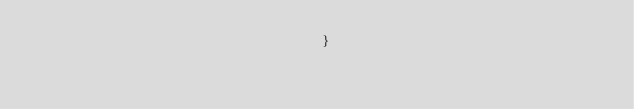<code> <loc_0><loc_0><loc_500><loc_500><_HTML_>									}</code> 